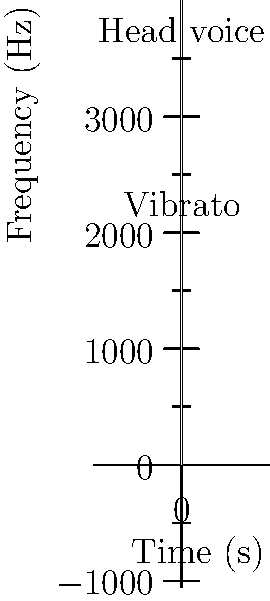Analyze the spectrogram of a J-pop vocal performance shown above. Which vocal technique is clearly visible in the lower frequency range (around 2000-2500 Hz) and is characterized by a wavy pattern in the spectral energy? To identify the vocal technique in the given spectrogram, let's analyze it step-by-step:

1. Observe the overall structure of the spectrogram:
   - The x-axis represents time, and the y-axis represents frequency.
   - Darker areas indicate higher spectral energy (louder sounds).

2. Focus on the lower frequency range (2000-2500 Hz):
   - There's a noticeable wavy pattern in this region.

3. Identify the characteristics of this wavy pattern:
   - It shows regular oscillations in pitch over time.
   - The pattern is consistent and controlled.

4. Compare this to known vocal techniques:
   - Vibrato is a technique where pitch is varied slightly and regularly.
   - The wavy pattern observed is a classic representation of vibrato in a spectrogram.

5. Confirm with the label:
   - The spectrogram is labeled with "Vibrato" pointing to this exact region.

6. Consider other techniques:
   - Head voice is labeled in a higher frequency range, which is correct but not the answer to this specific question.

Therefore, the vocal technique clearly visible in the lower frequency range and characterized by a wavy pattern in the spectral energy is vibrato.
Answer: Vibrato 